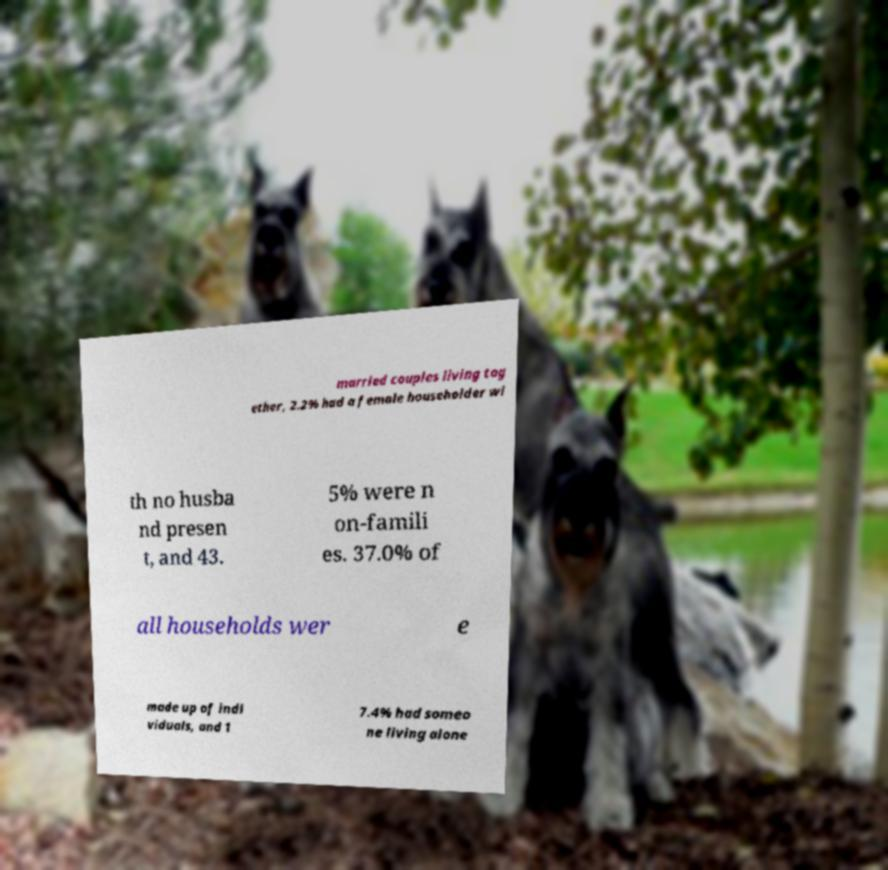I need the written content from this picture converted into text. Can you do that? married couples living tog ether, 2.2% had a female householder wi th no husba nd presen t, and 43. 5% were n on-famili es. 37.0% of all households wer e made up of indi viduals, and 1 7.4% had someo ne living alone 